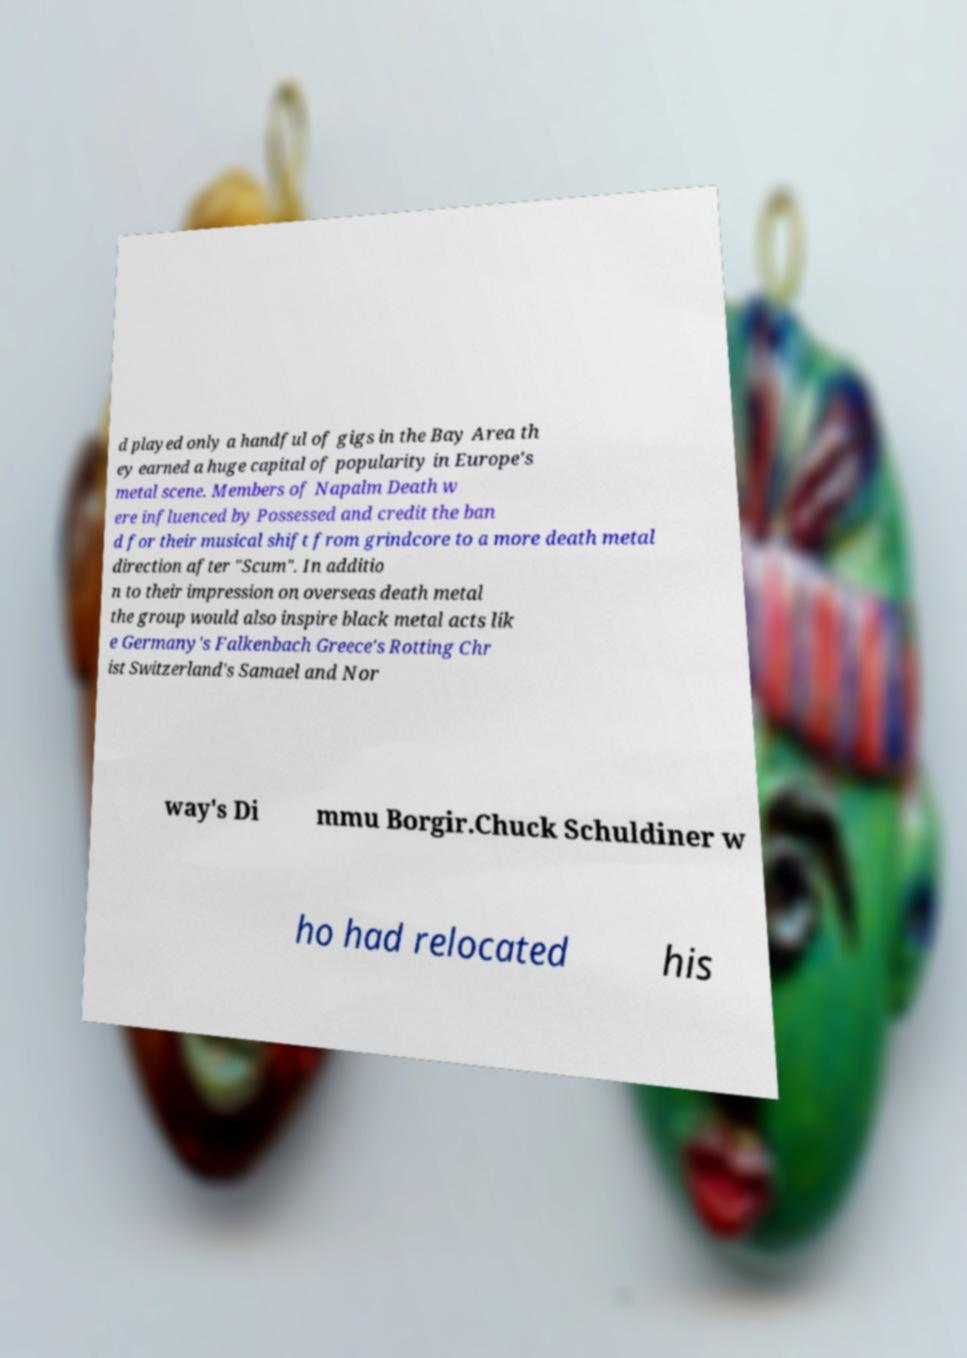Please identify and transcribe the text found in this image. d played only a handful of gigs in the Bay Area th ey earned a huge capital of popularity in Europe's metal scene. Members of Napalm Death w ere influenced by Possessed and credit the ban d for their musical shift from grindcore to a more death metal direction after "Scum". In additio n to their impression on overseas death metal the group would also inspire black metal acts lik e Germany's Falkenbach Greece's Rotting Chr ist Switzerland's Samael and Nor way's Di mmu Borgir.Chuck Schuldiner w ho had relocated his 